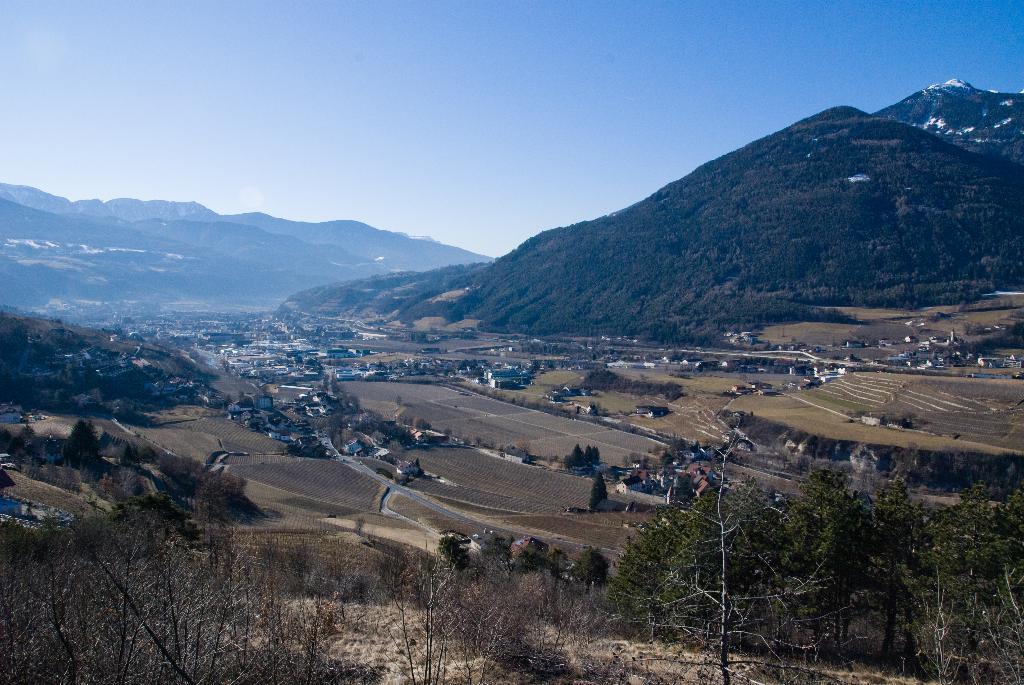What type of natural elements can be seen in the image? There are trees in the image. What type of man-made structures are present in the image? There are buildings in the image. What can be seen in the distance in the image? Hills are visible in the background of the image. What is visible above the trees and buildings in the image? The sky is visible in the image. Can you see any fairies flying around the trees in the image? There are no fairies present in the image; it features trees, buildings, hills, and the sky. What type of sweater is draped over the hill in the image? There is no sweater present in the image; it only features trees, buildings, hills, and the sky. 